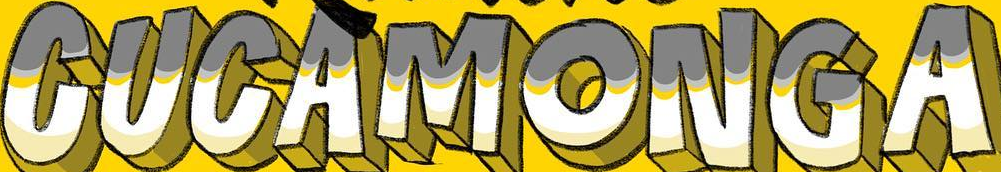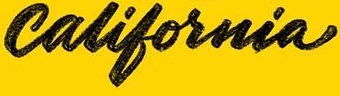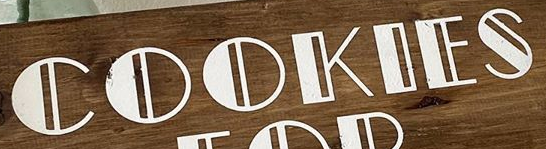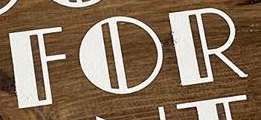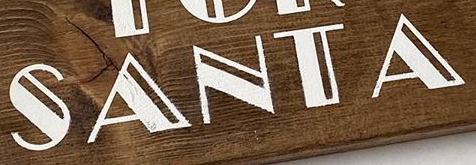What words are shown in these images in order, separated by a semicolon? CUCAMONGA; california; COOKIES; FOR; SANTA 